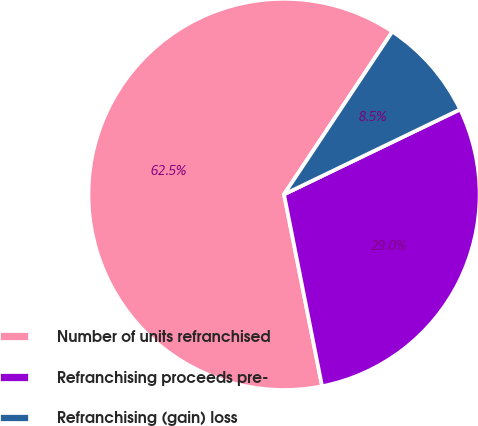Convert chart. <chart><loc_0><loc_0><loc_500><loc_500><pie_chart><fcel>Number of units refranchised<fcel>Refranchising proceeds pre-<fcel>Refranchising (gain) loss<nl><fcel>62.46%<fcel>29.04%<fcel>8.5%<nl></chart> 